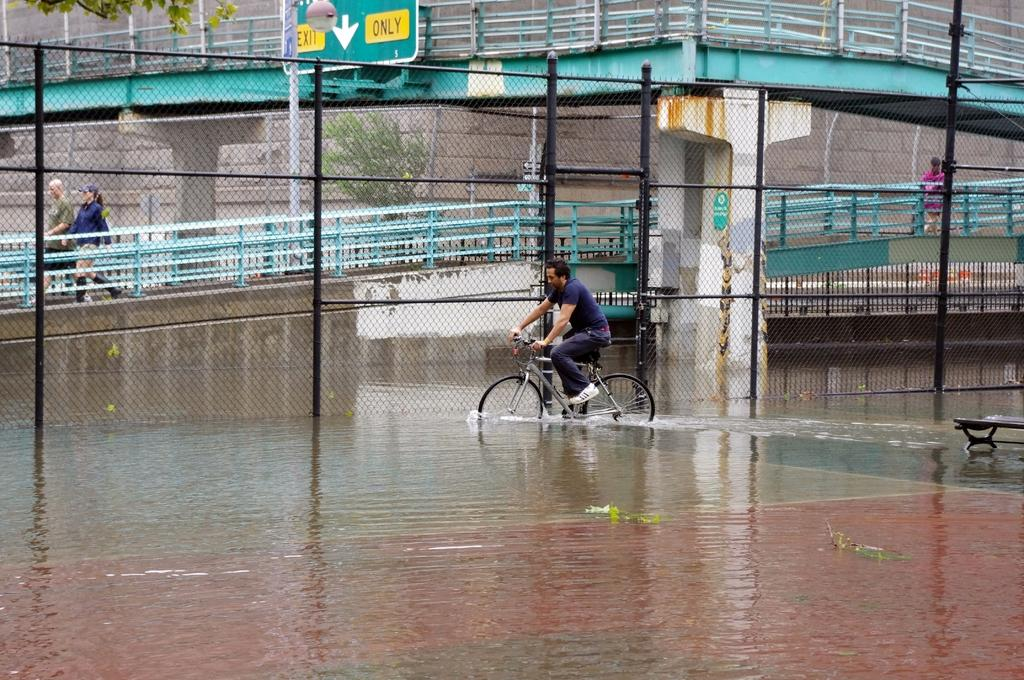What is the man in the image doing? The man is riding a bicycle on water in the image. What can be seen near the man? There is a bridge beside the man. What are the two people on the bridge doing? Two people are walking on the bridge. What type of hen can be seen walking on the bridge in the image? There is no hen present in the image; only the man riding a bicycle on water and the two people walking on the bridge are visible. 